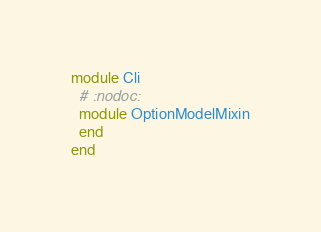Convert code to text. <code><loc_0><loc_0><loc_500><loc_500><_Crystal_>module Cli
  # :nodoc:
  module OptionModelMixin
  end
end
</code> 